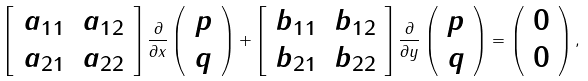<formula> <loc_0><loc_0><loc_500><loc_500>\left [ \begin{array} { c c } a _ { 1 1 } & a _ { 1 2 } \\ a _ { 2 1 } & a _ { 2 2 } \end{array} \right ] \frac { \partial } { \partial x } \left ( \begin{array} { c } p \\ q \end{array} \right ) + \left [ \begin{array} { c c } b _ { 1 1 } & b _ { 1 2 } \\ b _ { 2 1 } & b _ { 2 2 } \end{array} \right ] \frac { \partial } { \partial y } \left ( \begin{array} { c } p \\ q \end{array} \right ) = \left ( \begin{array} { c } 0 \\ 0 \end{array} \right ) ,</formula> 